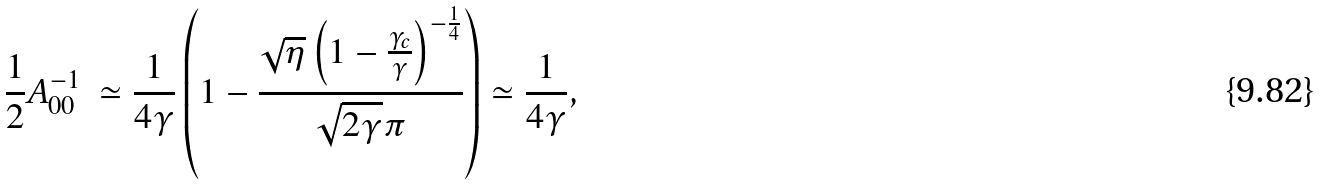<formula> <loc_0><loc_0><loc_500><loc_500>\frac { 1 } { 2 } A _ { 0 0 } ^ { - 1 } \ \simeq \frac { 1 } { 4 \gamma } \left ( 1 - \frac { \sqrt { \eta } \left ( 1 - \frac { \gamma _ { c } } { \gamma } \right ) ^ { - \frac { 1 } { 4 } } } { \sqrt { 2 \gamma } \pi } \right ) \simeq \frac { 1 } { 4 \gamma } ,</formula> 